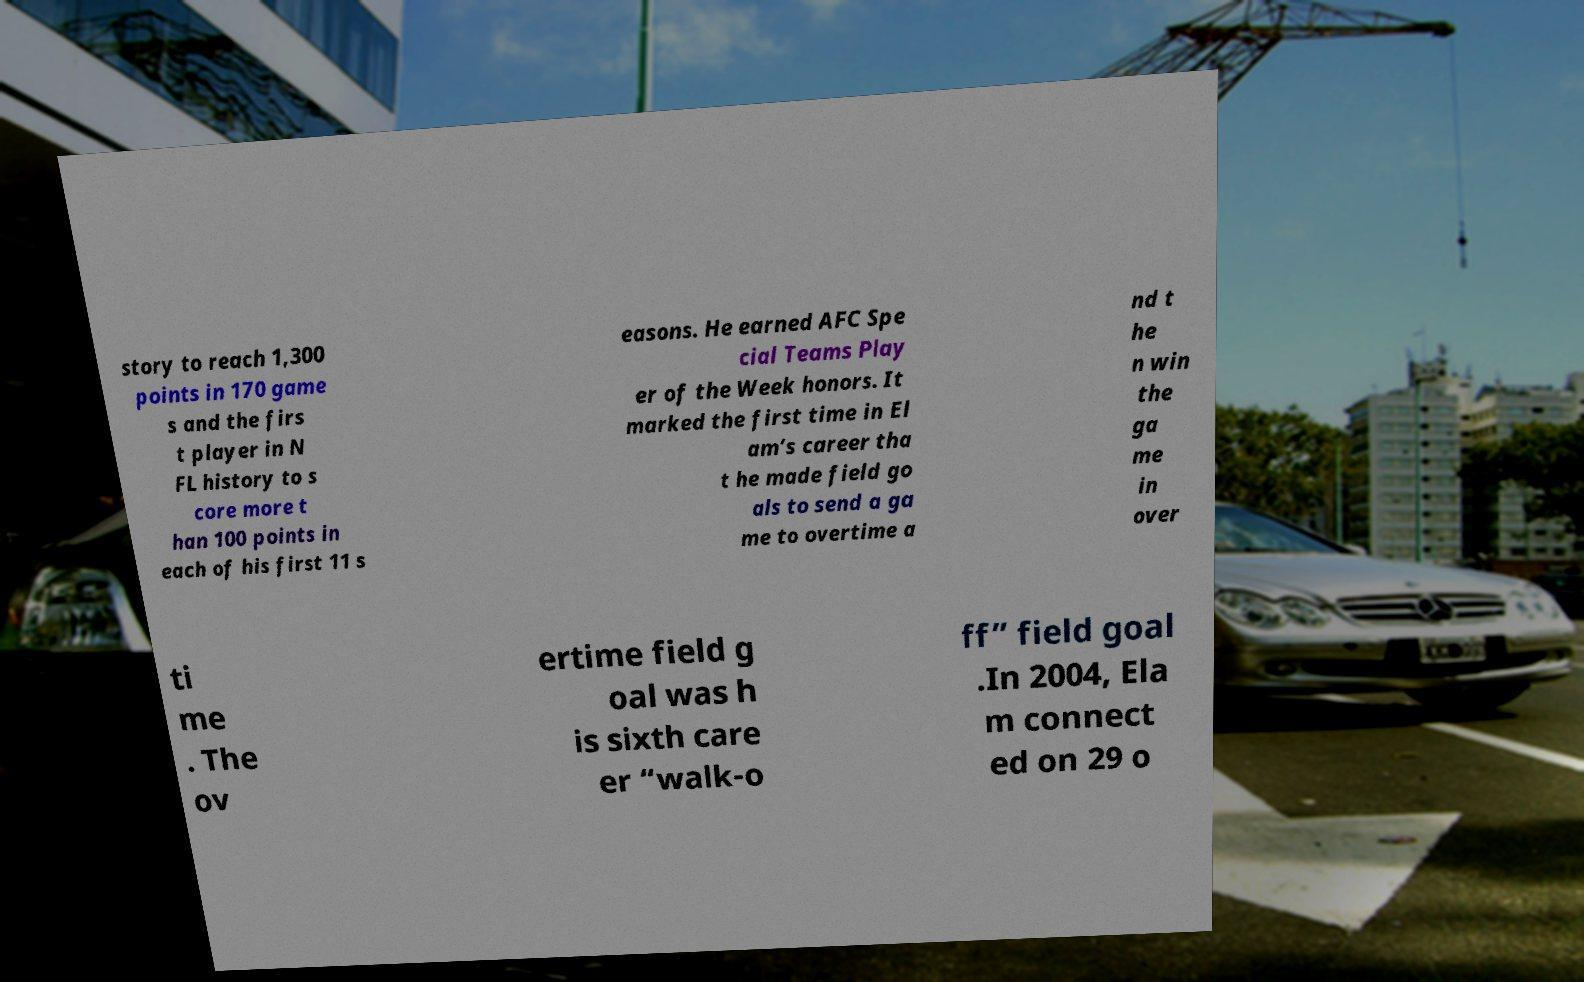Can you read and provide the text displayed in the image?This photo seems to have some interesting text. Can you extract and type it out for me? story to reach 1,300 points in 170 game s and the firs t player in N FL history to s core more t han 100 points in each of his first 11 s easons. He earned AFC Spe cial Teams Play er of the Week honors. It marked the first time in El am’s career tha t he made field go als to send a ga me to overtime a nd t he n win the ga me in over ti me . The ov ertime field g oal was h is sixth care er “walk-o ff” field goal .In 2004, Ela m connect ed on 29 o 